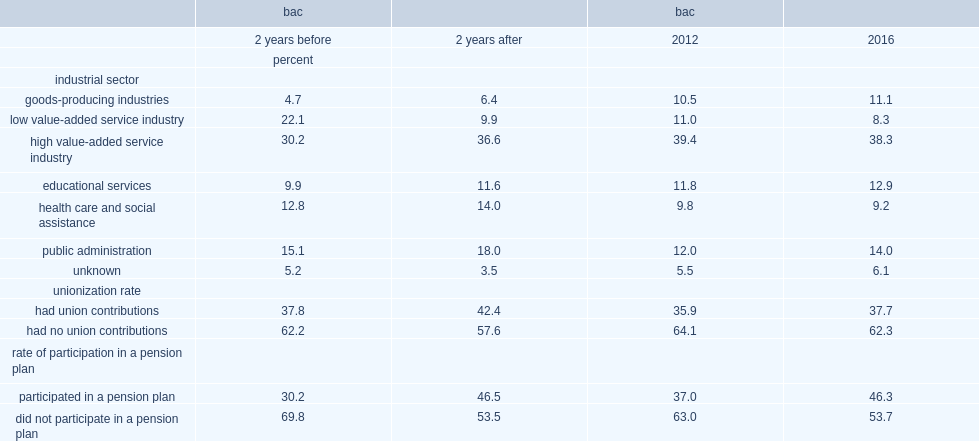In total, what was the proportion of bachelor graduates from 2010 who obtained an additional short-duration credential between 2013 and 2015 and who worked in low value-added service industries fell two years before obtaining the short-duration credential? 22.1. In total, what was the proportion of bachelor graduates from 2010 who obtained an additional short-duration credential between 2013 and 2015 and who worked in low value-added service industries fell two years after obtaining the short-duration credential? 9.9. What was the unionization rate increased betweeen two years before and two years after obtaining the short-duration credential? 4.6. 